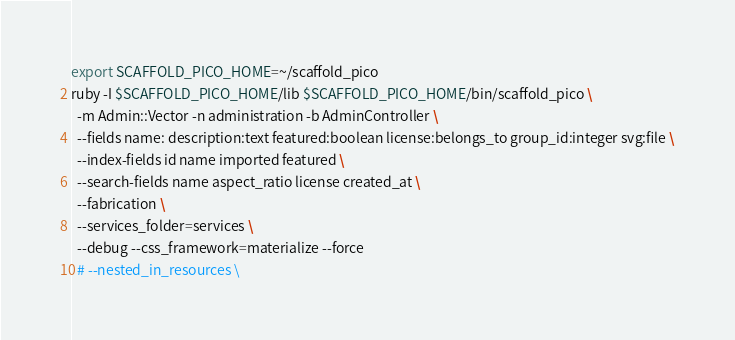<code> <loc_0><loc_0><loc_500><loc_500><_Bash_>export SCAFFOLD_PICO_HOME=~/scaffold_pico
ruby -I $SCAFFOLD_PICO_HOME/lib $SCAFFOLD_PICO_HOME/bin/scaffold_pico \
  -m Admin::Vector -n administration -b AdminController \
  --fields name: description:text featured:boolean license:belongs_to group_id:integer svg:file \
  --index-fields id name imported featured \
  --search-fields name aspect_ratio license created_at \
  --fabrication \
  --services_folder=services \
  --debug --css_framework=materialize --force
  # --nested_in_resources \
</code> 